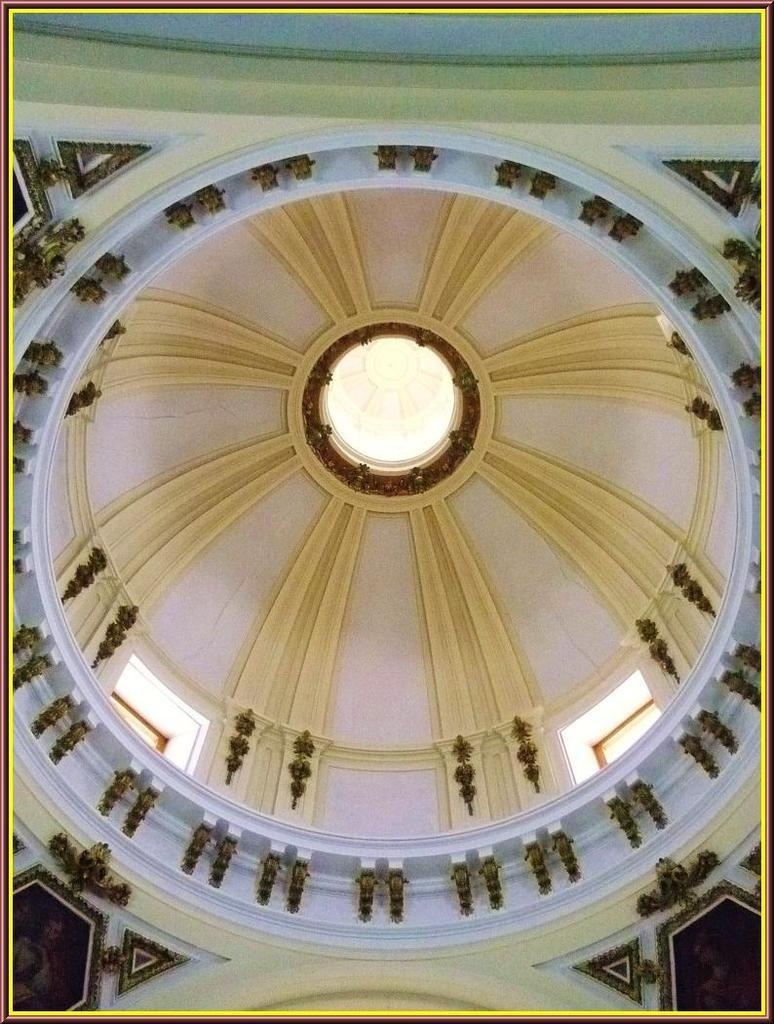What part of a building can be seen in the image? The image contains the roof of a building. What decorative features are present on the building's structure? There are carvings on the wall in the image. What type of decorative items are hanging on the wall? Wall hangings are present in the image. How many ants can be seen crawling on the wall in the image? There are no ants present in the image; it only features the roof of a building, carvings on the wall, and wall hangings. 